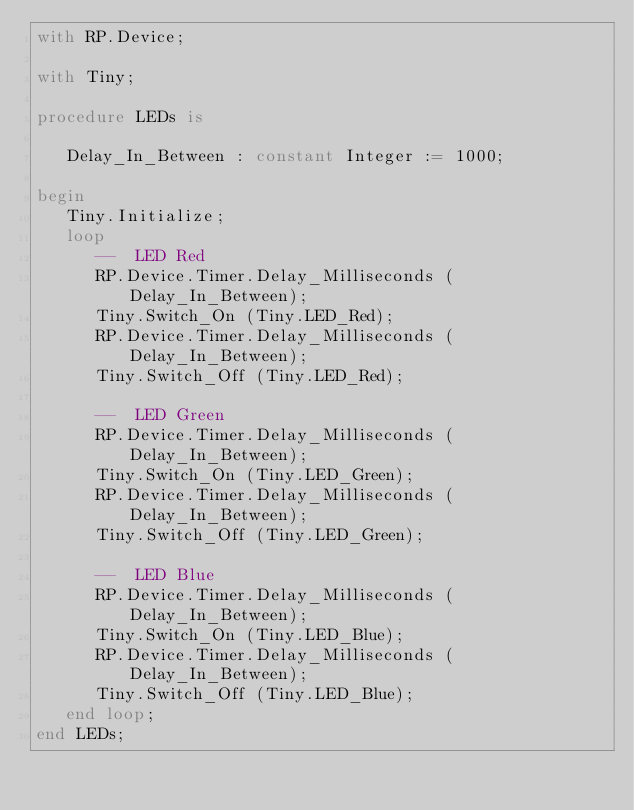<code> <loc_0><loc_0><loc_500><loc_500><_Ada_>with RP.Device;

with Tiny;

procedure LEDs is

   Delay_In_Between : constant Integer := 1000;

begin
   Tiny.Initialize;
   loop
      --  LED Red
      RP.Device.Timer.Delay_Milliseconds (Delay_In_Between);
      Tiny.Switch_On (Tiny.LED_Red);
      RP.Device.Timer.Delay_Milliseconds (Delay_In_Between);
      Tiny.Switch_Off (Tiny.LED_Red);

      --  LED Green
      RP.Device.Timer.Delay_Milliseconds (Delay_In_Between);
      Tiny.Switch_On (Tiny.LED_Green);
      RP.Device.Timer.Delay_Milliseconds (Delay_In_Between);
      Tiny.Switch_Off (Tiny.LED_Green);

      --  LED Blue
      RP.Device.Timer.Delay_Milliseconds (Delay_In_Between);
      Tiny.Switch_On (Tiny.LED_Blue);
      RP.Device.Timer.Delay_Milliseconds (Delay_In_Between);
      Tiny.Switch_Off (Tiny.LED_Blue);
   end loop;
end LEDs;
</code> 